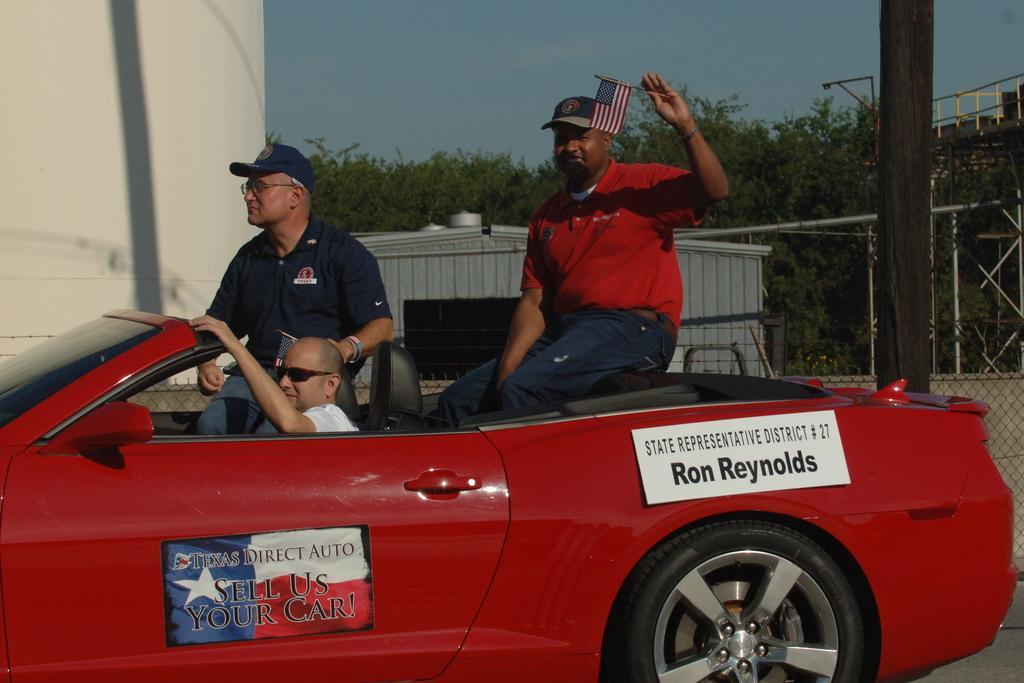Please provide a concise description of this image. Three persons are sitting on a car. The car is red in color. Two posters are on the car. The person wearing a red t shirt is holding a flag and wearing a cap. In the background there are trees, a wall and some buildings over there. 